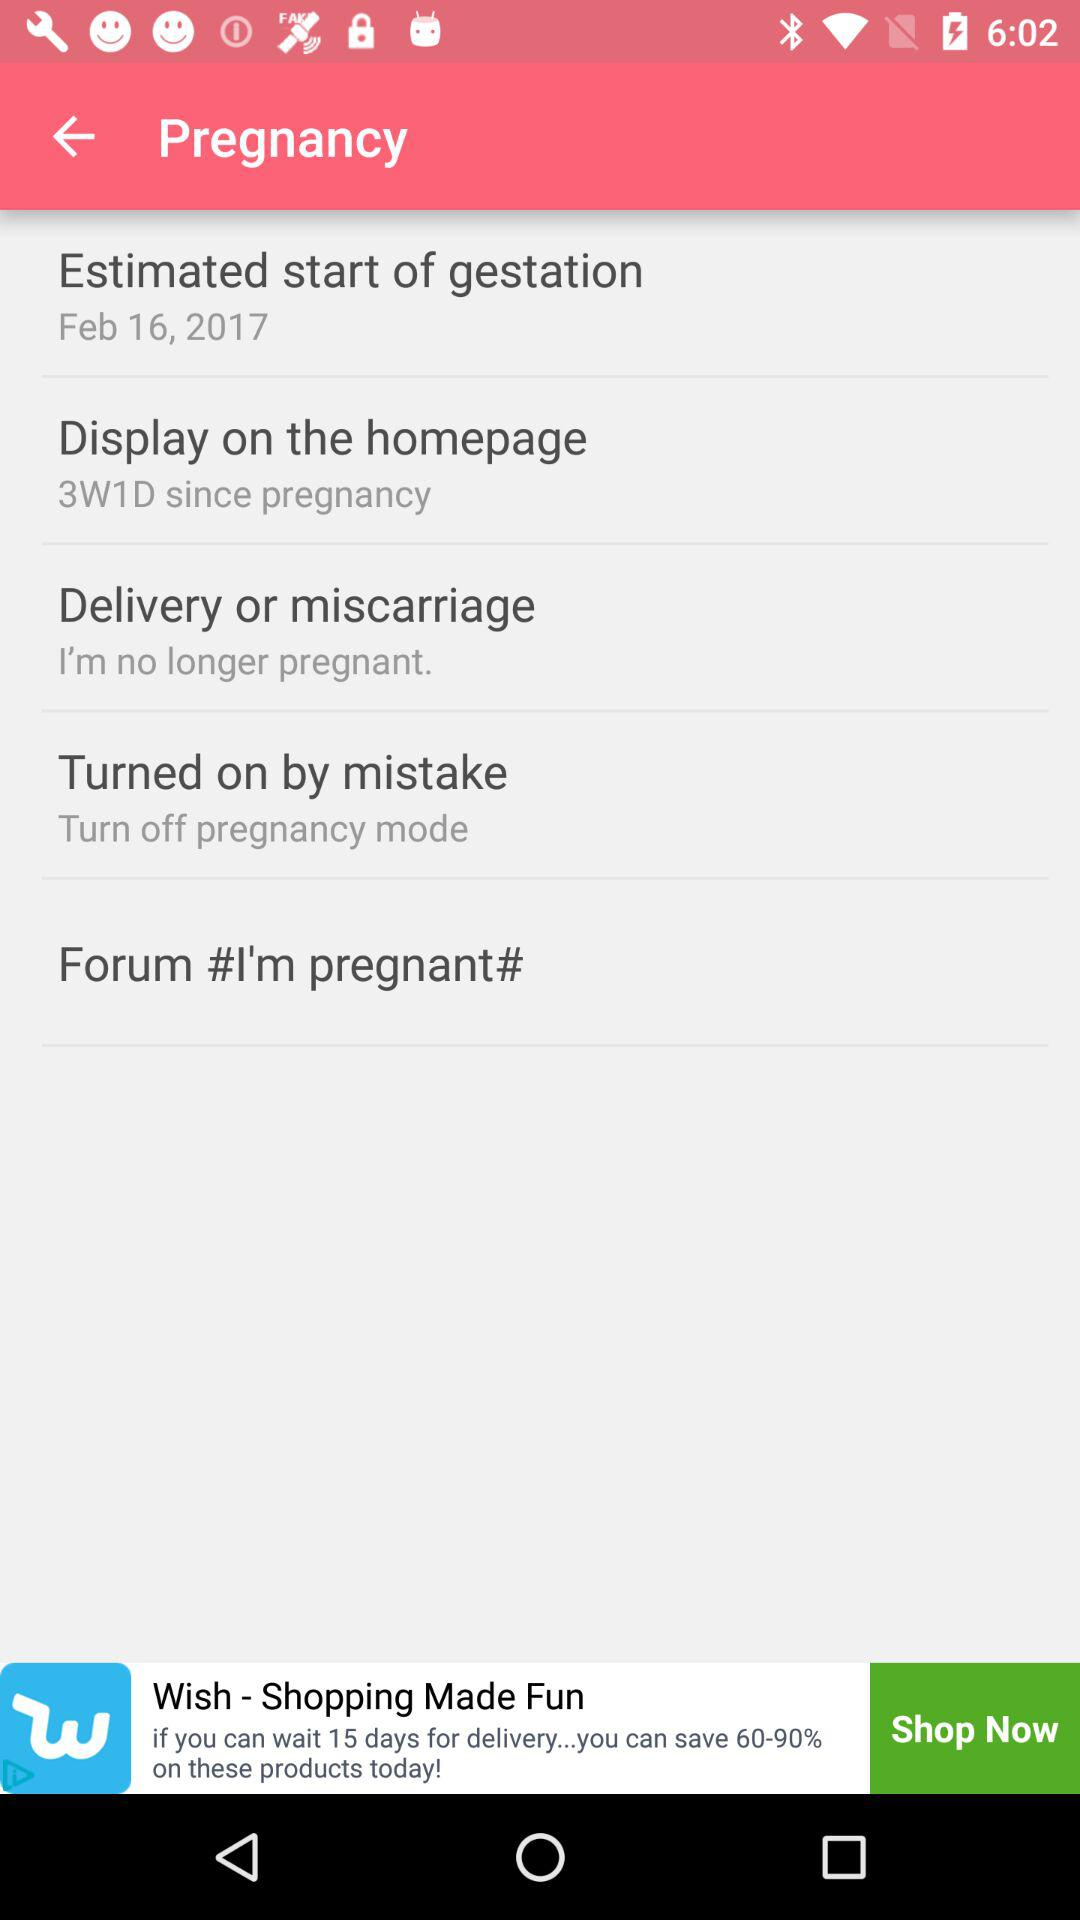What is the starting date of gestation? The starting date of gestation is February 16, 2017. 